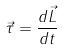Convert formula to latex. <formula><loc_0><loc_0><loc_500><loc_500>\vec { \tau } = \frac { d \vec { L } } { d t }</formula> 